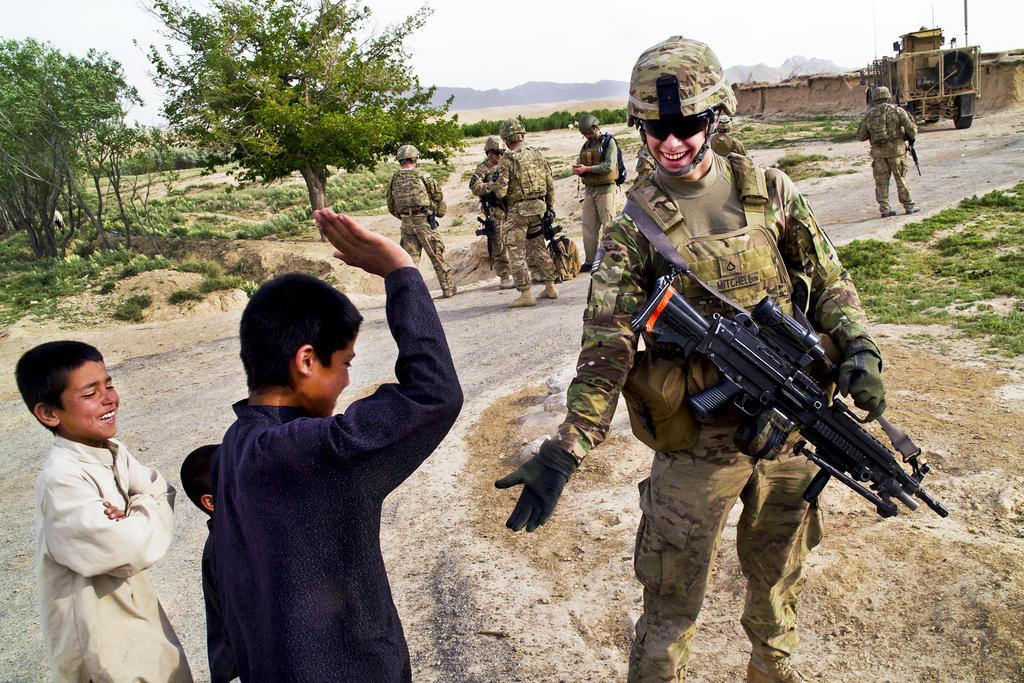Describe this image in one or two sentences. In this image we can see people standing. They are all wearing uniforms and we can see rifles. On the left there are boys smiling. In the background there are trees, hills and sky. On the right there is a vehicle. 